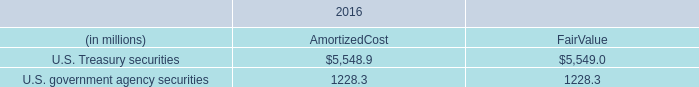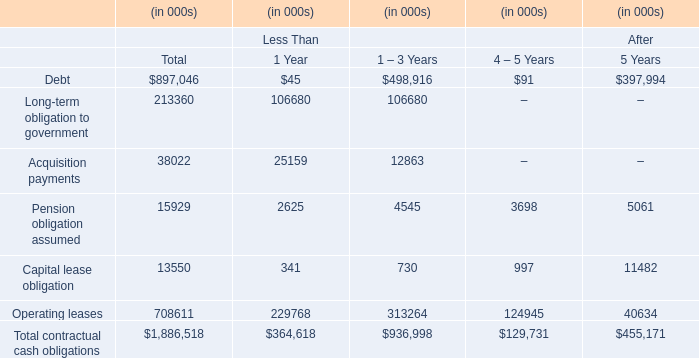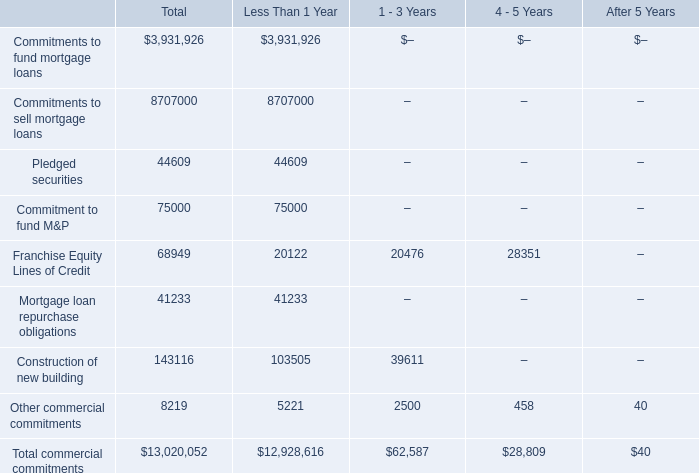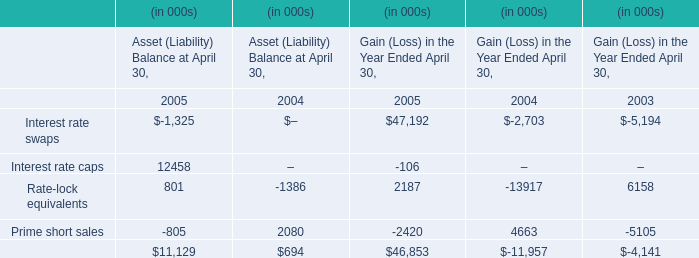what was the ratio of the cme cash account at the federal reserve bank of chicago in 2017 compared to 2016 
Computations: (34.2 / 6.2)
Answer: 5.51613. 